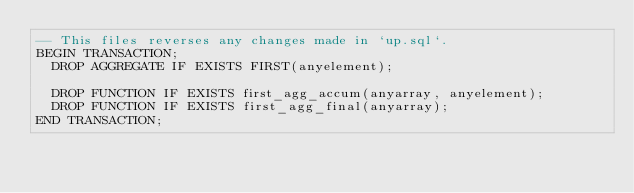<code> <loc_0><loc_0><loc_500><loc_500><_SQL_>-- This files reverses any changes made in `up.sql`.
BEGIN TRANSACTION;
	DROP AGGREGATE IF EXISTS FIRST(anyelement);
	
	DROP FUNCTION IF EXISTS first_agg_accum(anyarray, anyelement);
	DROP FUNCTION IF EXISTS first_agg_final(anyarray);
END TRANSACTION;
</code> 